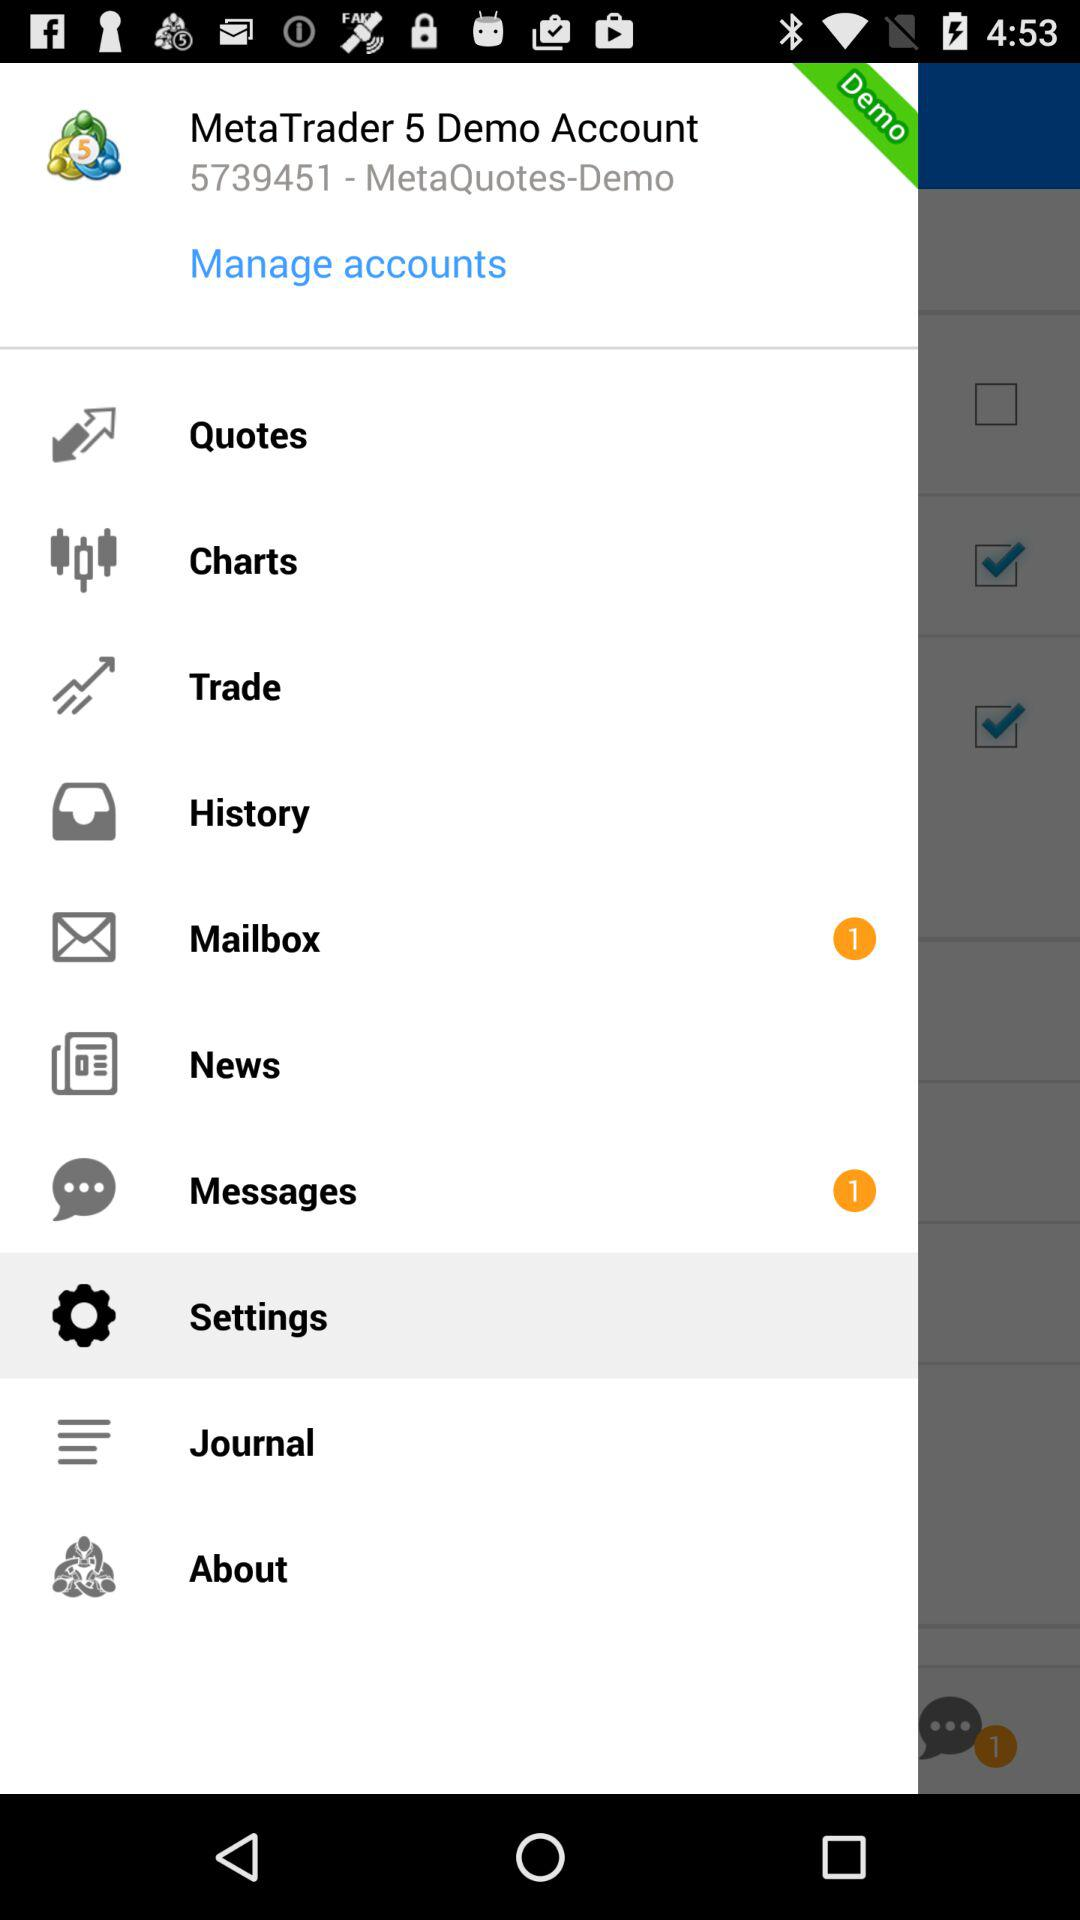What is the demo account ID? The demo account ID is 5739451. 